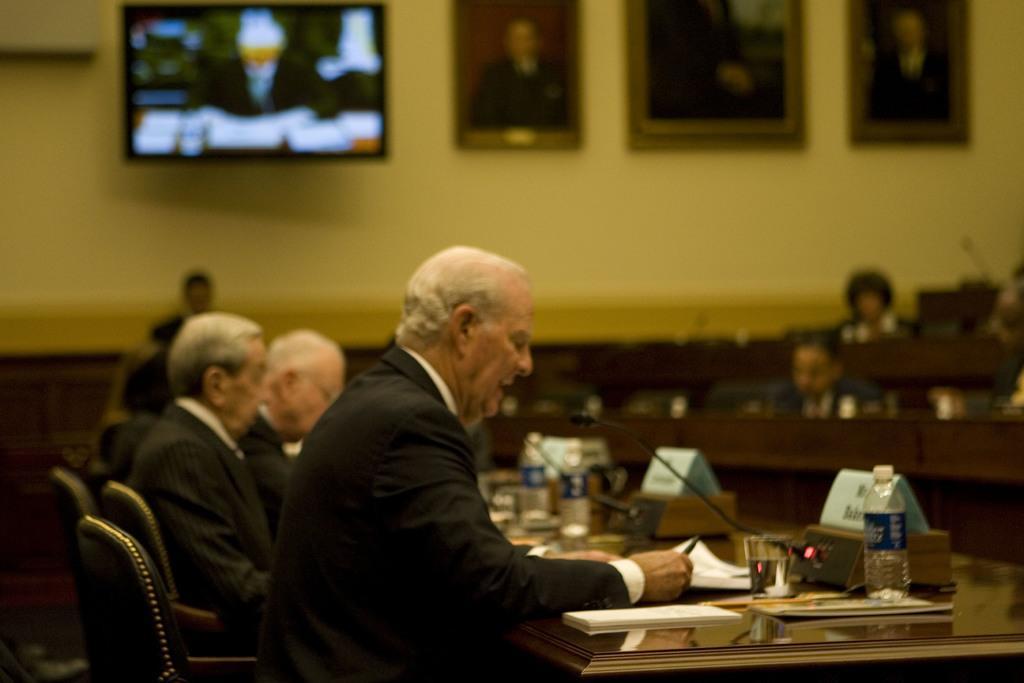Please provide a concise description of this image. There are group of persons sitting on the chair. This is a table. On this table I can see a tumbler with water,a water bottle,mike,name board and some papers on it. At the background I can see photo frames attached to the wall. And two persons are sitting on the chair in front of the table. 